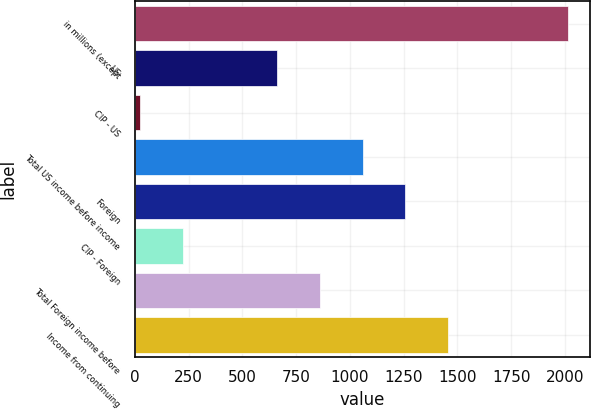<chart> <loc_0><loc_0><loc_500><loc_500><bar_chart><fcel>in millions (except<fcel>US<fcel>CIP - US<fcel>Total US income before income<fcel>Foreign<fcel>CIP - Foreign<fcel>Total Foreign income before<fcel>Income from continuing<nl><fcel>2015<fcel>661.9<fcel>26<fcel>1059.7<fcel>1258.6<fcel>224.9<fcel>860.8<fcel>1457.5<nl></chart> 